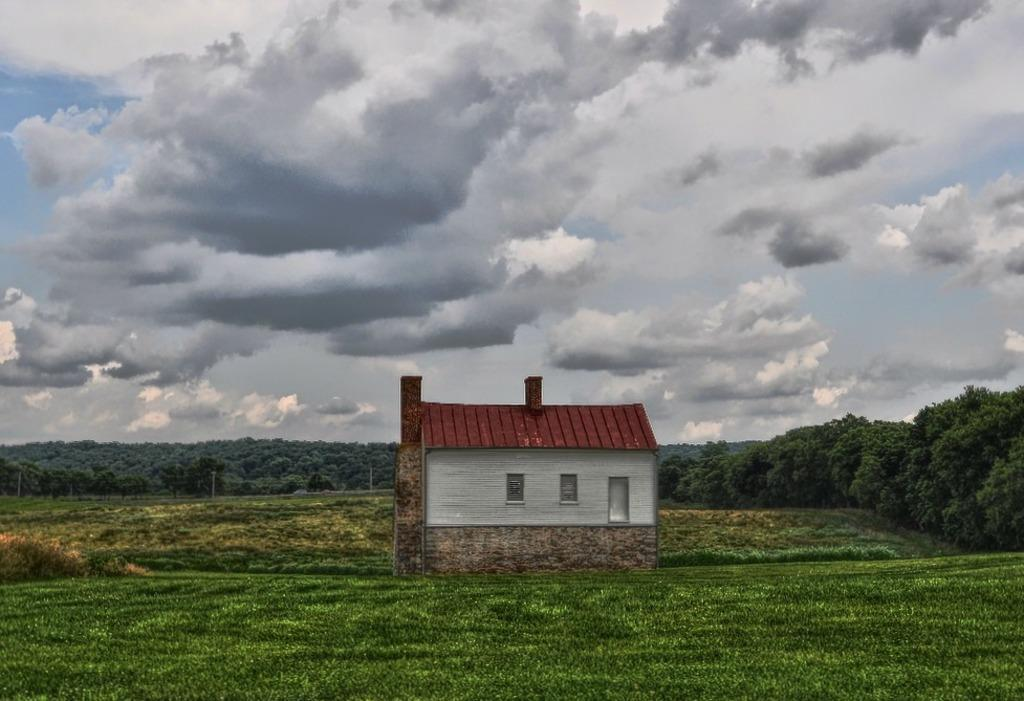What type of structure is present in the image? There is a house in the image. What type of vegetation can be seen in the image? There is grass in the image. What can be seen in the background of the image? There are many trees and clouds visible in the background of the image. What part of the natural environment is visible in the image? The sky is visible in the background of the image. What shape does the existence take in the image? The concept of existence is not a tangible object or shape that can be seen in the image. 